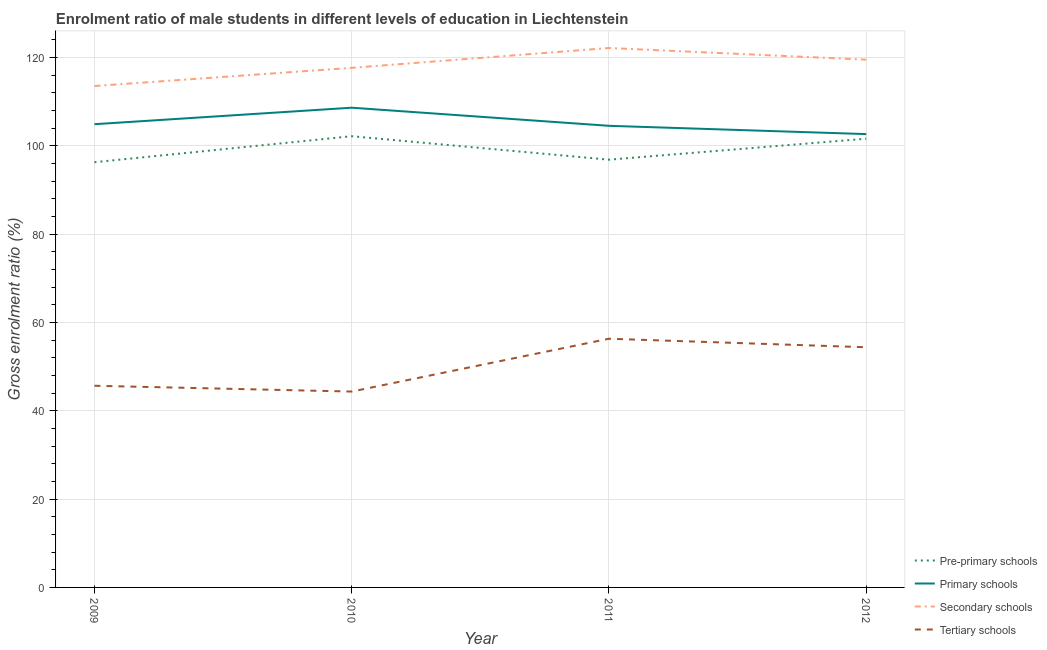How many different coloured lines are there?
Offer a very short reply. 4. Does the line corresponding to gross enrolment ratio(female) in pre-primary schools intersect with the line corresponding to gross enrolment ratio(female) in tertiary schools?
Offer a very short reply. No. What is the gross enrolment ratio(female) in tertiary schools in 2009?
Your answer should be very brief. 45.66. Across all years, what is the maximum gross enrolment ratio(female) in secondary schools?
Make the answer very short. 122.12. Across all years, what is the minimum gross enrolment ratio(female) in primary schools?
Your answer should be very brief. 102.63. In which year was the gross enrolment ratio(female) in tertiary schools maximum?
Your answer should be compact. 2011. What is the total gross enrolment ratio(female) in tertiary schools in the graph?
Offer a very short reply. 200.68. What is the difference between the gross enrolment ratio(female) in tertiary schools in 2010 and that in 2011?
Keep it short and to the point. -11.96. What is the difference between the gross enrolment ratio(female) in pre-primary schools in 2012 and the gross enrolment ratio(female) in primary schools in 2010?
Your answer should be compact. -7.02. What is the average gross enrolment ratio(female) in pre-primary schools per year?
Provide a succinct answer. 99.21. In the year 2009, what is the difference between the gross enrolment ratio(female) in secondary schools and gross enrolment ratio(female) in primary schools?
Give a very brief answer. 8.65. What is the ratio of the gross enrolment ratio(female) in tertiary schools in 2010 to that in 2012?
Give a very brief answer. 0.82. Is the difference between the gross enrolment ratio(female) in primary schools in 2009 and 2010 greater than the difference between the gross enrolment ratio(female) in secondary schools in 2009 and 2010?
Give a very brief answer. Yes. What is the difference between the highest and the second highest gross enrolment ratio(female) in secondary schools?
Give a very brief answer. 2.64. What is the difference between the highest and the lowest gross enrolment ratio(female) in tertiary schools?
Your answer should be very brief. 11.96. Is it the case that in every year, the sum of the gross enrolment ratio(female) in secondary schools and gross enrolment ratio(female) in pre-primary schools is greater than the sum of gross enrolment ratio(female) in primary schools and gross enrolment ratio(female) in tertiary schools?
Keep it short and to the point. No. Does the gross enrolment ratio(female) in pre-primary schools monotonically increase over the years?
Provide a succinct answer. No. How many lines are there?
Your response must be concise. 4. Does the graph contain grids?
Provide a succinct answer. Yes. Where does the legend appear in the graph?
Give a very brief answer. Bottom right. How are the legend labels stacked?
Provide a succinct answer. Vertical. What is the title of the graph?
Provide a short and direct response. Enrolment ratio of male students in different levels of education in Liechtenstein. Does "Secondary vocational" appear as one of the legend labels in the graph?
Keep it short and to the point. No. What is the label or title of the X-axis?
Your answer should be compact. Year. What is the Gross enrolment ratio (%) in Pre-primary schools in 2009?
Give a very brief answer. 96.27. What is the Gross enrolment ratio (%) of Primary schools in 2009?
Keep it short and to the point. 104.87. What is the Gross enrolment ratio (%) of Secondary schools in 2009?
Ensure brevity in your answer.  113.52. What is the Gross enrolment ratio (%) of Tertiary schools in 2009?
Provide a succinct answer. 45.66. What is the Gross enrolment ratio (%) of Pre-primary schools in 2010?
Your answer should be very brief. 102.15. What is the Gross enrolment ratio (%) of Primary schools in 2010?
Your response must be concise. 108.61. What is the Gross enrolment ratio (%) in Secondary schools in 2010?
Provide a succinct answer. 117.64. What is the Gross enrolment ratio (%) in Tertiary schools in 2010?
Offer a terse response. 44.34. What is the Gross enrolment ratio (%) in Pre-primary schools in 2011?
Your answer should be compact. 96.84. What is the Gross enrolment ratio (%) in Primary schools in 2011?
Your answer should be compact. 104.51. What is the Gross enrolment ratio (%) in Secondary schools in 2011?
Your response must be concise. 122.12. What is the Gross enrolment ratio (%) of Tertiary schools in 2011?
Offer a terse response. 56.3. What is the Gross enrolment ratio (%) of Pre-primary schools in 2012?
Ensure brevity in your answer.  101.59. What is the Gross enrolment ratio (%) of Primary schools in 2012?
Provide a short and direct response. 102.63. What is the Gross enrolment ratio (%) in Secondary schools in 2012?
Give a very brief answer. 119.48. What is the Gross enrolment ratio (%) in Tertiary schools in 2012?
Offer a terse response. 54.37. Across all years, what is the maximum Gross enrolment ratio (%) in Pre-primary schools?
Make the answer very short. 102.15. Across all years, what is the maximum Gross enrolment ratio (%) of Primary schools?
Your answer should be compact. 108.61. Across all years, what is the maximum Gross enrolment ratio (%) of Secondary schools?
Your answer should be very brief. 122.12. Across all years, what is the maximum Gross enrolment ratio (%) of Tertiary schools?
Offer a terse response. 56.3. Across all years, what is the minimum Gross enrolment ratio (%) in Pre-primary schools?
Your answer should be compact. 96.27. Across all years, what is the minimum Gross enrolment ratio (%) in Primary schools?
Make the answer very short. 102.63. Across all years, what is the minimum Gross enrolment ratio (%) of Secondary schools?
Ensure brevity in your answer.  113.52. Across all years, what is the minimum Gross enrolment ratio (%) in Tertiary schools?
Your response must be concise. 44.34. What is the total Gross enrolment ratio (%) in Pre-primary schools in the graph?
Give a very brief answer. 396.85. What is the total Gross enrolment ratio (%) of Primary schools in the graph?
Your answer should be very brief. 420.62. What is the total Gross enrolment ratio (%) in Secondary schools in the graph?
Ensure brevity in your answer.  472.76. What is the total Gross enrolment ratio (%) in Tertiary schools in the graph?
Keep it short and to the point. 200.68. What is the difference between the Gross enrolment ratio (%) of Pre-primary schools in 2009 and that in 2010?
Your response must be concise. -5.88. What is the difference between the Gross enrolment ratio (%) of Primary schools in 2009 and that in 2010?
Give a very brief answer. -3.74. What is the difference between the Gross enrolment ratio (%) of Secondary schools in 2009 and that in 2010?
Offer a terse response. -4.12. What is the difference between the Gross enrolment ratio (%) in Tertiary schools in 2009 and that in 2010?
Make the answer very short. 1.31. What is the difference between the Gross enrolment ratio (%) of Pre-primary schools in 2009 and that in 2011?
Provide a short and direct response. -0.58. What is the difference between the Gross enrolment ratio (%) in Primary schools in 2009 and that in 2011?
Offer a terse response. 0.36. What is the difference between the Gross enrolment ratio (%) in Secondary schools in 2009 and that in 2011?
Your answer should be very brief. -8.61. What is the difference between the Gross enrolment ratio (%) of Tertiary schools in 2009 and that in 2011?
Ensure brevity in your answer.  -10.65. What is the difference between the Gross enrolment ratio (%) in Pre-primary schools in 2009 and that in 2012?
Keep it short and to the point. -5.32. What is the difference between the Gross enrolment ratio (%) in Primary schools in 2009 and that in 2012?
Keep it short and to the point. 2.24. What is the difference between the Gross enrolment ratio (%) of Secondary schools in 2009 and that in 2012?
Offer a terse response. -5.97. What is the difference between the Gross enrolment ratio (%) of Tertiary schools in 2009 and that in 2012?
Make the answer very short. -8.72. What is the difference between the Gross enrolment ratio (%) in Pre-primary schools in 2010 and that in 2011?
Provide a short and direct response. 5.31. What is the difference between the Gross enrolment ratio (%) of Primary schools in 2010 and that in 2011?
Your answer should be compact. 4.1. What is the difference between the Gross enrolment ratio (%) of Secondary schools in 2010 and that in 2011?
Provide a succinct answer. -4.49. What is the difference between the Gross enrolment ratio (%) in Tertiary schools in 2010 and that in 2011?
Your answer should be very brief. -11.96. What is the difference between the Gross enrolment ratio (%) in Pre-primary schools in 2010 and that in 2012?
Your answer should be compact. 0.56. What is the difference between the Gross enrolment ratio (%) in Primary schools in 2010 and that in 2012?
Your answer should be very brief. 5.97. What is the difference between the Gross enrolment ratio (%) in Secondary schools in 2010 and that in 2012?
Make the answer very short. -1.85. What is the difference between the Gross enrolment ratio (%) of Tertiary schools in 2010 and that in 2012?
Your response must be concise. -10.03. What is the difference between the Gross enrolment ratio (%) of Pre-primary schools in 2011 and that in 2012?
Ensure brevity in your answer.  -4.75. What is the difference between the Gross enrolment ratio (%) of Primary schools in 2011 and that in 2012?
Keep it short and to the point. 1.88. What is the difference between the Gross enrolment ratio (%) in Secondary schools in 2011 and that in 2012?
Your response must be concise. 2.64. What is the difference between the Gross enrolment ratio (%) in Tertiary schools in 2011 and that in 2012?
Provide a short and direct response. 1.93. What is the difference between the Gross enrolment ratio (%) of Pre-primary schools in 2009 and the Gross enrolment ratio (%) of Primary schools in 2010?
Keep it short and to the point. -12.34. What is the difference between the Gross enrolment ratio (%) of Pre-primary schools in 2009 and the Gross enrolment ratio (%) of Secondary schools in 2010?
Your answer should be very brief. -21.37. What is the difference between the Gross enrolment ratio (%) of Pre-primary schools in 2009 and the Gross enrolment ratio (%) of Tertiary schools in 2010?
Ensure brevity in your answer.  51.92. What is the difference between the Gross enrolment ratio (%) in Primary schools in 2009 and the Gross enrolment ratio (%) in Secondary schools in 2010?
Give a very brief answer. -12.76. What is the difference between the Gross enrolment ratio (%) in Primary schools in 2009 and the Gross enrolment ratio (%) in Tertiary schools in 2010?
Your answer should be compact. 60.53. What is the difference between the Gross enrolment ratio (%) of Secondary schools in 2009 and the Gross enrolment ratio (%) of Tertiary schools in 2010?
Offer a terse response. 69.17. What is the difference between the Gross enrolment ratio (%) of Pre-primary schools in 2009 and the Gross enrolment ratio (%) of Primary schools in 2011?
Make the answer very short. -8.24. What is the difference between the Gross enrolment ratio (%) in Pre-primary schools in 2009 and the Gross enrolment ratio (%) in Secondary schools in 2011?
Your answer should be compact. -25.86. What is the difference between the Gross enrolment ratio (%) of Pre-primary schools in 2009 and the Gross enrolment ratio (%) of Tertiary schools in 2011?
Offer a very short reply. 39.96. What is the difference between the Gross enrolment ratio (%) of Primary schools in 2009 and the Gross enrolment ratio (%) of Secondary schools in 2011?
Provide a succinct answer. -17.25. What is the difference between the Gross enrolment ratio (%) in Primary schools in 2009 and the Gross enrolment ratio (%) in Tertiary schools in 2011?
Provide a succinct answer. 48.57. What is the difference between the Gross enrolment ratio (%) in Secondary schools in 2009 and the Gross enrolment ratio (%) in Tertiary schools in 2011?
Give a very brief answer. 57.21. What is the difference between the Gross enrolment ratio (%) in Pre-primary schools in 2009 and the Gross enrolment ratio (%) in Primary schools in 2012?
Provide a short and direct response. -6.36. What is the difference between the Gross enrolment ratio (%) in Pre-primary schools in 2009 and the Gross enrolment ratio (%) in Secondary schools in 2012?
Your answer should be compact. -23.22. What is the difference between the Gross enrolment ratio (%) of Pre-primary schools in 2009 and the Gross enrolment ratio (%) of Tertiary schools in 2012?
Provide a succinct answer. 41.89. What is the difference between the Gross enrolment ratio (%) in Primary schools in 2009 and the Gross enrolment ratio (%) in Secondary schools in 2012?
Offer a terse response. -14.61. What is the difference between the Gross enrolment ratio (%) of Primary schools in 2009 and the Gross enrolment ratio (%) of Tertiary schools in 2012?
Your response must be concise. 50.5. What is the difference between the Gross enrolment ratio (%) of Secondary schools in 2009 and the Gross enrolment ratio (%) of Tertiary schools in 2012?
Offer a very short reply. 59.14. What is the difference between the Gross enrolment ratio (%) in Pre-primary schools in 2010 and the Gross enrolment ratio (%) in Primary schools in 2011?
Ensure brevity in your answer.  -2.36. What is the difference between the Gross enrolment ratio (%) of Pre-primary schools in 2010 and the Gross enrolment ratio (%) of Secondary schools in 2011?
Your response must be concise. -19.97. What is the difference between the Gross enrolment ratio (%) in Pre-primary schools in 2010 and the Gross enrolment ratio (%) in Tertiary schools in 2011?
Ensure brevity in your answer.  45.85. What is the difference between the Gross enrolment ratio (%) of Primary schools in 2010 and the Gross enrolment ratio (%) of Secondary schools in 2011?
Keep it short and to the point. -13.52. What is the difference between the Gross enrolment ratio (%) of Primary schools in 2010 and the Gross enrolment ratio (%) of Tertiary schools in 2011?
Give a very brief answer. 52.3. What is the difference between the Gross enrolment ratio (%) of Secondary schools in 2010 and the Gross enrolment ratio (%) of Tertiary schools in 2011?
Provide a succinct answer. 61.33. What is the difference between the Gross enrolment ratio (%) of Pre-primary schools in 2010 and the Gross enrolment ratio (%) of Primary schools in 2012?
Provide a short and direct response. -0.48. What is the difference between the Gross enrolment ratio (%) of Pre-primary schools in 2010 and the Gross enrolment ratio (%) of Secondary schools in 2012?
Provide a succinct answer. -17.33. What is the difference between the Gross enrolment ratio (%) of Pre-primary schools in 2010 and the Gross enrolment ratio (%) of Tertiary schools in 2012?
Give a very brief answer. 47.78. What is the difference between the Gross enrolment ratio (%) of Primary schools in 2010 and the Gross enrolment ratio (%) of Secondary schools in 2012?
Keep it short and to the point. -10.88. What is the difference between the Gross enrolment ratio (%) of Primary schools in 2010 and the Gross enrolment ratio (%) of Tertiary schools in 2012?
Your answer should be compact. 54.23. What is the difference between the Gross enrolment ratio (%) of Secondary schools in 2010 and the Gross enrolment ratio (%) of Tertiary schools in 2012?
Your answer should be very brief. 63.26. What is the difference between the Gross enrolment ratio (%) in Pre-primary schools in 2011 and the Gross enrolment ratio (%) in Primary schools in 2012?
Give a very brief answer. -5.79. What is the difference between the Gross enrolment ratio (%) of Pre-primary schools in 2011 and the Gross enrolment ratio (%) of Secondary schools in 2012?
Your answer should be compact. -22.64. What is the difference between the Gross enrolment ratio (%) of Pre-primary schools in 2011 and the Gross enrolment ratio (%) of Tertiary schools in 2012?
Provide a succinct answer. 42.47. What is the difference between the Gross enrolment ratio (%) in Primary schools in 2011 and the Gross enrolment ratio (%) in Secondary schools in 2012?
Offer a terse response. -14.97. What is the difference between the Gross enrolment ratio (%) in Primary schools in 2011 and the Gross enrolment ratio (%) in Tertiary schools in 2012?
Provide a short and direct response. 50.14. What is the difference between the Gross enrolment ratio (%) of Secondary schools in 2011 and the Gross enrolment ratio (%) of Tertiary schools in 2012?
Your response must be concise. 67.75. What is the average Gross enrolment ratio (%) in Pre-primary schools per year?
Offer a terse response. 99.21. What is the average Gross enrolment ratio (%) in Primary schools per year?
Make the answer very short. 105.15. What is the average Gross enrolment ratio (%) of Secondary schools per year?
Your answer should be very brief. 118.19. What is the average Gross enrolment ratio (%) of Tertiary schools per year?
Give a very brief answer. 50.17. In the year 2009, what is the difference between the Gross enrolment ratio (%) of Pre-primary schools and Gross enrolment ratio (%) of Primary schools?
Give a very brief answer. -8.6. In the year 2009, what is the difference between the Gross enrolment ratio (%) of Pre-primary schools and Gross enrolment ratio (%) of Secondary schools?
Provide a succinct answer. -17.25. In the year 2009, what is the difference between the Gross enrolment ratio (%) of Pre-primary schools and Gross enrolment ratio (%) of Tertiary schools?
Keep it short and to the point. 50.61. In the year 2009, what is the difference between the Gross enrolment ratio (%) of Primary schools and Gross enrolment ratio (%) of Secondary schools?
Your response must be concise. -8.65. In the year 2009, what is the difference between the Gross enrolment ratio (%) of Primary schools and Gross enrolment ratio (%) of Tertiary schools?
Your answer should be compact. 59.21. In the year 2009, what is the difference between the Gross enrolment ratio (%) in Secondary schools and Gross enrolment ratio (%) in Tertiary schools?
Provide a succinct answer. 67.86. In the year 2010, what is the difference between the Gross enrolment ratio (%) in Pre-primary schools and Gross enrolment ratio (%) in Primary schools?
Your response must be concise. -6.46. In the year 2010, what is the difference between the Gross enrolment ratio (%) of Pre-primary schools and Gross enrolment ratio (%) of Secondary schools?
Give a very brief answer. -15.48. In the year 2010, what is the difference between the Gross enrolment ratio (%) of Pre-primary schools and Gross enrolment ratio (%) of Tertiary schools?
Offer a terse response. 57.81. In the year 2010, what is the difference between the Gross enrolment ratio (%) in Primary schools and Gross enrolment ratio (%) in Secondary schools?
Provide a succinct answer. -9.03. In the year 2010, what is the difference between the Gross enrolment ratio (%) of Primary schools and Gross enrolment ratio (%) of Tertiary schools?
Offer a very short reply. 64.26. In the year 2010, what is the difference between the Gross enrolment ratio (%) of Secondary schools and Gross enrolment ratio (%) of Tertiary schools?
Provide a succinct answer. 73.29. In the year 2011, what is the difference between the Gross enrolment ratio (%) of Pre-primary schools and Gross enrolment ratio (%) of Primary schools?
Your answer should be very brief. -7.67. In the year 2011, what is the difference between the Gross enrolment ratio (%) in Pre-primary schools and Gross enrolment ratio (%) in Secondary schools?
Your response must be concise. -25.28. In the year 2011, what is the difference between the Gross enrolment ratio (%) in Pre-primary schools and Gross enrolment ratio (%) in Tertiary schools?
Give a very brief answer. 40.54. In the year 2011, what is the difference between the Gross enrolment ratio (%) in Primary schools and Gross enrolment ratio (%) in Secondary schools?
Provide a short and direct response. -17.62. In the year 2011, what is the difference between the Gross enrolment ratio (%) of Primary schools and Gross enrolment ratio (%) of Tertiary schools?
Your answer should be very brief. 48.2. In the year 2011, what is the difference between the Gross enrolment ratio (%) in Secondary schools and Gross enrolment ratio (%) in Tertiary schools?
Offer a very short reply. 65.82. In the year 2012, what is the difference between the Gross enrolment ratio (%) in Pre-primary schools and Gross enrolment ratio (%) in Primary schools?
Give a very brief answer. -1.04. In the year 2012, what is the difference between the Gross enrolment ratio (%) in Pre-primary schools and Gross enrolment ratio (%) in Secondary schools?
Ensure brevity in your answer.  -17.89. In the year 2012, what is the difference between the Gross enrolment ratio (%) of Pre-primary schools and Gross enrolment ratio (%) of Tertiary schools?
Provide a short and direct response. 47.22. In the year 2012, what is the difference between the Gross enrolment ratio (%) in Primary schools and Gross enrolment ratio (%) in Secondary schools?
Give a very brief answer. -16.85. In the year 2012, what is the difference between the Gross enrolment ratio (%) of Primary schools and Gross enrolment ratio (%) of Tertiary schools?
Make the answer very short. 48.26. In the year 2012, what is the difference between the Gross enrolment ratio (%) in Secondary schools and Gross enrolment ratio (%) in Tertiary schools?
Provide a short and direct response. 65.11. What is the ratio of the Gross enrolment ratio (%) of Pre-primary schools in 2009 to that in 2010?
Your answer should be very brief. 0.94. What is the ratio of the Gross enrolment ratio (%) in Primary schools in 2009 to that in 2010?
Keep it short and to the point. 0.97. What is the ratio of the Gross enrolment ratio (%) in Tertiary schools in 2009 to that in 2010?
Give a very brief answer. 1.03. What is the ratio of the Gross enrolment ratio (%) of Pre-primary schools in 2009 to that in 2011?
Your answer should be very brief. 0.99. What is the ratio of the Gross enrolment ratio (%) of Primary schools in 2009 to that in 2011?
Your answer should be very brief. 1. What is the ratio of the Gross enrolment ratio (%) in Secondary schools in 2009 to that in 2011?
Offer a terse response. 0.93. What is the ratio of the Gross enrolment ratio (%) in Tertiary schools in 2009 to that in 2011?
Make the answer very short. 0.81. What is the ratio of the Gross enrolment ratio (%) of Pre-primary schools in 2009 to that in 2012?
Your response must be concise. 0.95. What is the ratio of the Gross enrolment ratio (%) of Primary schools in 2009 to that in 2012?
Give a very brief answer. 1.02. What is the ratio of the Gross enrolment ratio (%) in Secondary schools in 2009 to that in 2012?
Your answer should be very brief. 0.95. What is the ratio of the Gross enrolment ratio (%) of Tertiary schools in 2009 to that in 2012?
Provide a short and direct response. 0.84. What is the ratio of the Gross enrolment ratio (%) of Pre-primary schools in 2010 to that in 2011?
Your answer should be compact. 1.05. What is the ratio of the Gross enrolment ratio (%) in Primary schools in 2010 to that in 2011?
Make the answer very short. 1.04. What is the ratio of the Gross enrolment ratio (%) of Secondary schools in 2010 to that in 2011?
Keep it short and to the point. 0.96. What is the ratio of the Gross enrolment ratio (%) of Tertiary schools in 2010 to that in 2011?
Keep it short and to the point. 0.79. What is the ratio of the Gross enrolment ratio (%) in Primary schools in 2010 to that in 2012?
Offer a terse response. 1.06. What is the ratio of the Gross enrolment ratio (%) in Secondary schools in 2010 to that in 2012?
Provide a succinct answer. 0.98. What is the ratio of the Gross enrolment ratio (%) of Tertiary schools in 2010 to that in 2012?
Offer a terse response. 0.82. What is the ratio of the Gross enrolment ratio (%) in Pre-primary schools in 2011 to that in 2012?
Your response must be concise. 0.95. What is the ratio of the Gross enrolment ratio (%) in Primary schools in 2011 to that in 2012?
Your answer should be compact. 1.02. What is the ratio of the Gross enrolment ratio (%) of Secondary schools in 2011 to that in 2012?
Ensure brevity in your answer.  1.02. What is the ratio of the Gross enrolment ratio (%) of Tertiary schools in 2011 to that in 2012?
Make the answer very short. 1.04. What is the difference between the highest and the second highest Gross enrolment ratio (%) of Pre-primary schools?
Provide a succinct answer. 0.56. What is the difference between the highest and the second highest Gross enrolment ratio (%) of Primary schools?
Make the answer very short. 3.74. What is the difference between the highest and the second highest Gross enrolment ratio (%) in Secondary schools?
Provide a short and direct response. 2.64. What is the difference between the highest and the second highest Gross enrolment ratio (%) in Tertiary schools?
Your answer should be compact. 1.93. What is the difference between the highest and the lowest Gross enrolment ratio (%) in Pre-primary schools?
Keep it short and to the point. 5.88. What is the difference between the highest and the lowest Gross enrolment ratio (%) of Primary schools?
Your answer should be compact. 5.97. What is the difference between the highest and the lowest Gross enrolment ratio (%) of Secondary schools?
Make the answer very short. 8.61. What is the difference between the highest and the lowest Gross enrolment ratio (%) of Tertiary schools?
Your answer should be compact. 11.96. 